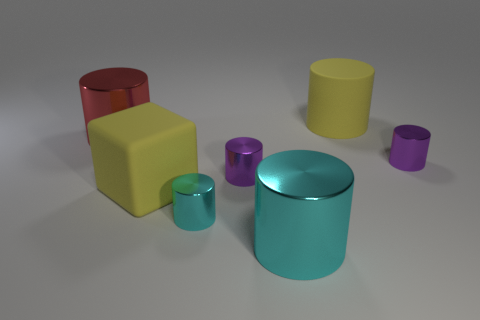Subtract all tiny purple cylinders. How many cylinders are left? 4 Subtract 3 cylinders. How many cylinders are left? 3 Subtract all purple cylinders. How many cylinders are left? 4 Subtract all green cylinders. Subtract all gray spheres. How many cylinders are left? 6 Add 1 small green matte spheres. How many objects exist? 8 Subtract all cubes. How many objects are left? 6 Subtract 0 yellow balls. How many objects are left? 7 Subtract all purple things. Subtract all rubber cylinders. How many objects are left? 4 Add 5 big red cylinders. How many big red cylinders are left? 6 Add 7 large yellow metallic objects. How many large yellow metallic objects exist? 7 